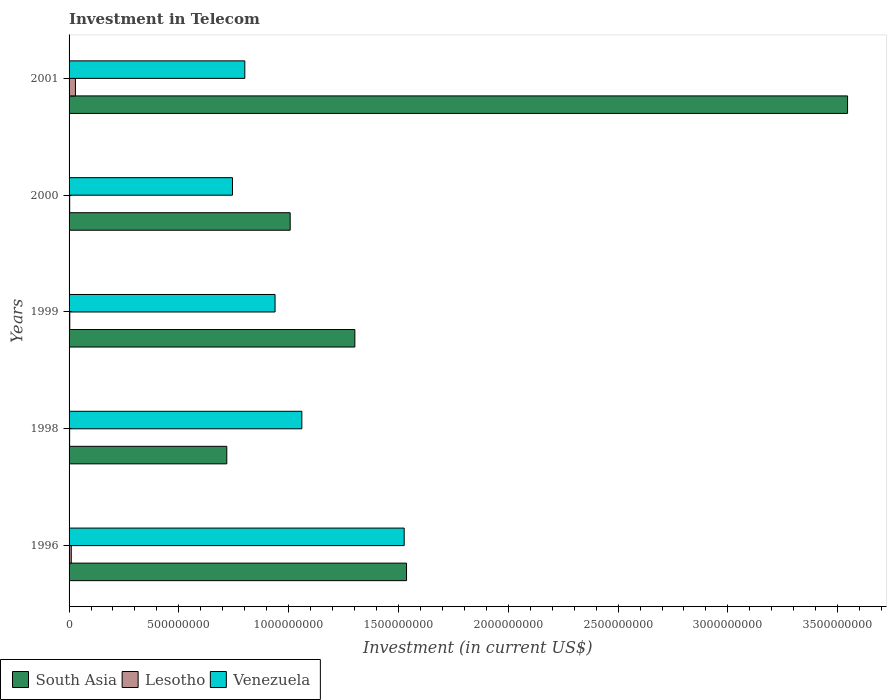How many groups of bars are there?
Provide a short and direct response. 5. Are the number of bars on each tick of the Y-axis equal?
Your answer should be very brief. Yes. How many bars are there on the 4th tick from the top?
Provide a short and direct response. 3. What is the label of the 4th group of bars from the top?
Provide a succinct answer. 1998. In how many cases, is the number of bars for a given year not equal to the number of legend labels?
Your answer should be very brief. 0. What is the amount invested in telecom in Lesotho in 1998?
Provide a succinct answer. 2.50e+06. Across all years, what is the maximum amount invested in telecom in South Asia?
Keep it short and to the point. 3.54e+09. Across all years, what is the minimum amount invested in telecom in Venezuela?
Your response must be concise. 7.44e+08. In which year was the amount invested in telecom in South Asia minimum?
Your answer should be very brief. 1998. What is the total amount invested in telecom in South Asia in the graph?
Your response must be concise. 8.11e+09. What is the difference between the amount invested in telecom in Venezuela in 1998 and that in 2000?
Offer a terse response. 3.16e+08. What is the difference between the amount invested in telecom in South Asia in 1996 and the amount invested in telecom in Venezuela in 1998?
Your answer should be compact. 4.77e+08. What is the average amount invested in telecom in Venezuela per year?
Ensure brevity in your answer.  1.01e+09. In the year 2001, what is the difference between the amount invested in telecom in Venezuela and amount invested in telecom in Lesotho?
Make the answer very short. 7.71e+08. What is the ratio of the amount invested in telecom in Lesotho in 1998 to that in 2000?
Your response must be concise. 0.89. Is the amount invested in telecom in Venezuela in 1996 less than that in 1999?
Your answer should be very brief. No. What is the difference between the highest and the second highest amount invested in telecom in South Asia?
Ensure brevity in your answer.  2.01e+09. What is the difference between the highest and the lowest amount invested in telecom in Lesotho?
Your answer should be very brief. 2.65e+07. In how many years, is the amount invested in telecom in Venezuela greater than the average amount invested in telecom in Venezuela taken over all years?
Offer a very short reply. 2. Is the sum of the amount invested in telecom in Venezuela in 1996 and 2001 greater than the maximum amount invested in telecom in South Asia across all years?
Offer a terse response. No. What does the 2nd bar from the top in 1999 represents?
Your answer should be compact. Lesotho. Is it the case that in every year, the sum of the amount invested in telecom in Lesotho and amount invested in telecom in Venezuela is greater than the amount invested in telecom in South Asia?
Give a very brief answer. No. How many bars are there?
Offer a very short reply. 15. Are all the bars in the graph horizontal?
Offer a terse response. Yes. What is the difference between two consecutive major ticks on the X-axis?
Keep it short and to the point. 5.00e+08. Does the graph contain any zero values?
Give a very brief answer. No. Does the graph contain grids?
Provide a short and direct response. No. How are the legend labels stacked?
Give a very brief answer. Horizontal. What is the title of the graph?
Your answer should be compact. Investment in Telecom. What is the label or title of the X-axis?
Your answer should be very brief. Investment (in current US$). What is the Investment (in current US$) in South Asia in 1996?
Ensure brevity in your answer.  1.54e+09. What is the Investment (in current US$) of Lesotho in 1996?
Provide a short and direct response. 1.00e+07. What is the Investment (in current US$) of Venezuela in 1996?
Your response must be concise. 1.53e+09. What is the Investment (in current US$) in South Asia in 1998?
Keep it short and to the point. 7.18e+08. What is the Investment (in current US$) in Lesotho in 1998?
Your answer should be compact. 2.50e+06. What is the Investment (in current US$) of Venezuela in 1998?
Your response must be concise. 1.06e+09. What is the Investment (in current US$) in South Asia in 1999?
Offer a terse response. 1.30e+09. What is the Investment (in current US$) in Lesotho in 1999?
Provide a succinct answer. 3.20e+06. What is the Investment (in current US$) in Venezuela in 1999?
Your answer should be compact. 9.38e+08. What is the Investment (in current US$) of South Asia in 2000?
Your answer should be compact. 1.01e+09. What is the Investment (in current US$) of Lesotho in 2000?
Make the answer very short. 2.80e+06. What is the Investment (in current US$) in Venezuela in 2000?
Offer a terse response. 7.44e+08. What is the Investment (in current US$) in South Asia in 2001?
Provide a short and direct response. 3.54e+09. What is the Investment (in current US$) of Lesotho in 2001?
Offer a terse response. 2.90e+07. What is the Investment (in current US$) in Venezuela in 2001?
Ensure brevity in your answer.  8.00e+08. Across all years, what is the maximum Investment (in current US$) of South Asia?
Provide a succinct answer. 3.54e+09. Across all years, what is the maximum Investment (in current US$) in Lesotho?
Your response must be concise. 2.90e+07. Across all years, what is the maximum Investment (in current US$) of Venezuela?
Keep it short and to the point. 1.53e+09. Across all years, what is the minimum Investment (in current US$) of South Asia?
Provide a succinct answer. 7.18e+08. Across all years, what is the minimum Investment (in current US$) in Lesotho?
Your answer should be compact. 2.50e+06. Across all years, what is the minimum Investment (in current US$) of Venezuela?
Provide a short and direct response. 7.44e+08. What is the total Investment (in current US$) in South Asia in the graph?
Make the answer very short. 8.11e+09. What is the total Investment (in current US$) in Lesotho in the graph?
Make the answer very short. 4.75e+07. What is the total Investment (in current US$) in Venezuela in the graph?
Provide a succinct answer. 5.07e+09. What is the difference between the Investment (in current US$) in South Asia in 1996 and that in 1998?
Your response must be concise. 8.18e+08. What is the difference between the Investment (in current US$) in Lesotho in 1996 and that in 1998?
Provide a succinct answer. 7.50e+06. What is the difference between the Investment (in current US$) in Venezuela in 1996 and that in 1998?
Provide a succinct answer. 4.66e+08. What is the difference between the Investment (in current US$) of South Asia in 1996 and that in 1999?
Offer a terse response. 2.35e+08. What is the difference between the Investment (in current US$) in Lesotho in 1996 and that in 1999?
Your answer should be very brief. 6.80e+06. What is the difference between the Investment (in current US$) of Venezuela in 1996 and that in 1999?
Your answer should be compact. 5.88e+08. What is the difference between the Investment (in current US$) in South Asia in 1996 and that in 2000?
Provide a succinct answer. 5.30e+08. What is the difference between the Investment (in current US$) in Lesotho in 1996 and that in 2000?
Ensure brevity in your answer.  7.20e+06. What is the difference between the Investment (in current US$) in Venezuela in 1996 and that in 2000?
Your answer should be compact. 7.82e+08. What is the difference between the Investment (in current US$) in South Asia in 1996 and that in 2001?
Provide a short and direct response. -2.01e+09. What is the difference between the Investment (in current US$) of Lesotho in 1996 and that in 2001?
Offer a terse response. -1.90e+07. What is the difference between the Investment (in current US$) of Venezuela in 1996 and that in 2001?
Your answer should be very brief. 7.26e+08. What is the difference between the Investment (in current US$) of South Asia in 1998 and that in 1999?
Ensure brevity in your answer.  -5.83e+08. What is the difference between the Investment (in current US$) of Lesotho in 1998 and that in 1999?
Offer a terse response. -7.00e+05. What is the difference between the Investment (in current US$) in Venezuela in 1998 and that in 1999?
Ensure brevity in your answer.  1.22e+08. What is the difference between the Investment (in current US$) of South Asia in 1998 and that in 2000?
Your answer should be compact. -2.89e+08. What is the difference between the Investment (in current US$) of Venezuela in 1998 and that in 2000?
Your answer should be compact. 3.16e+08. What is the difference between the Investment (in current US$) in South Asia in 1998 and that in 2001?
Your answer should be compact. -2.83e+09. What is the difference between the Investment (in current US$) in Lesotho in 1998 and that in 2001?
Provide a short and direct response. -2.65e+07. What is the difference between the Investment (in current US$) in Venezuela in 1998 and that in 2001?
Your response must be concise. 2.60e+08. What is the difference between the Investment (in current US$) in South Asia in 1999 and that in 2000?
Give a very brief answer. 2.94e+08. What is the difference between the Investment (in current US$) in Venezuela in 1999 and that in 2000?
Give a very brief answer. 1.94e+08. What is the difference between the Investment (in current US$) in South Asia in 1999 and that in 2001?
Offer a terse response. -2.24e+09. What is the difference between the Investment (in current US$) of Lesotho in 1999 and that in 2001?
Provide a succinct answer. -2.58e+07. What is the difference between the Investment (in current US$) in Venezuela in 1999 and that in 2001?
Your answer should be very brief. 1.38e+08. What is the difference between the Investment (in current US$) in South Asia in 2000 and that in 2001?
Ensure brevity in your answer.  -2.54e+09. What is the difference between the Investment (in current US$) in Lesotho in 2000 and that in 2001?
Give a very brief answer. -2.62e+07. What is the difference between the Investment (in current US$) of Venezuela in 2000 and that in 2001?
Keep it short and to the point. -5.62e+07. What is the difference between the Investment (in current US$) in South Asia in 1996 and the Investment (in current US$) in Lesotho in 1998?
Your answer should be compact. 1.53e+09. What is the difference between the Investment (in current US$) of South Asia in 1996 and the Investment (in current US$) of Venezuela in 1998?
Provide a short and direct response. 4.77e+08. What is the difference between the Investment (in current US$) in Lesotho in 1996 and the Investment (in current US$) in Venezuela in 1998?
Your answer should be compact. -1.05e+09. What is the difference between the Investment (in current US$) of South Asia in 1996 and the Investment (in current US$) of Lesotho in 1999?
Ensure brevity in your answer.  1.53e+09. What is the difference between the Investment (in current US$) of South Asia in 1996 and the Investment (in current US$) of Venezuela in 1999?
Keep it short and to the point. 5.99e+08. What is the difference between the Investment (in current US$) of Lesotho in 1996 and the Investment (in current US$) of Venezuela in 1999?
Ensure brevity in your answer.  -9.28e+08. What is the difference between the Investment (in current US$) in South Asia in 1996 and the Investment (in current US$) in Lesotho in 2000?
Offer a very short reply. 1.53e+09. What is the difference between the Investment (in current US$) in South Asia in 1996 and the Investment (in current US$) in Venezuela in 2000?
Offer a terse response. 7.93e+08. What is the difference between the Investment (in current US$) of Lesotho in 1996 and the Investment (in current US$) of Venezuela in 2000?
Keep it short and to the point. -7.34e+08. What is the difference between the Investment (in current US$) in South Asia in 1996 and the Investment (in current US$) in Lesotho in 2001?
Give a very brief answer. 1.51e+09. What is the difference between the Investment (in current US$) in South Asia in 1996 and the Investment (in current US$) in Venezuela in 2001?
Your answer should be very brief. 7.36e+08. What is the difference between the Investment (in current US$) in Lesotho in 1996 and the Investment (in current US$) in Venezuela in 2001?
Offer a very short reply. -7.90e+08. What is the difference between the Investment (in current US$) of South Asia in 1998 and the Investment (in current US$) of Lesotho in 1999?
Give a very brief answer. 7.15e+08. What is the difference between the Investment (in current US$) in South Asia in 1998 and the Investment (in current US$) in Venezuela in 1999?
Keep it short and to the point. -2.20e+08. What is the difference between the Investment (in current US$) of Lesotho in 1998 and the Investment (in current US$) of Venezuela in 1999?
Provide a short and direct response. -9.36e+08. What is the difference between the Investment (in current US$) of South Asia in 1998 and the Investment (in current US$) of Lesotho in 2000?
Give a very brief answer. 7.15e+08. What is the difference between the Investment (in current US$) in South Asia in 1998 and the Investment (in current US$) in Venezuela in 2000?
Offer a terse response. -2.59e+07. What is the difference between the Investment (in current US$) in Lesotho in 1998 and the Investment (in current US$) in Venezuela in 2000?
Your answer should be very brief. -7.42e+08. What is the difference between the Investment (in current US$) of South Asia in 1998 and the Investment (in current US$) of Lesotho in 2001?
Keep it short and to the point. 6.89e+08. What is the difference between the Investment (in current US$) of South Asia in 1998 and the Investment (in current US$) of Venezuela in 2001?
Your answer should be very brief. -8.21e+07. What is the difference between the Investment (in current US$) of Lesotho in 1998 and the Investment (in current US$) of Venezuela in 2001?
Give a very brief answer. -7.98e+08. What is the difference between the Investment (in current US$) of South Asia in 1999 and the Investment (in current US$) of Lesotho in 2000?
Offer a terse response. 1.30e+09. What is the difference between the Investment (in current US$) of South Asia in 1999 and the Investment (in current US$) of Venezuela in 2000?
Offer a terse response. 5.57e+08. What is the difference between the Investment (in current US$) of Lesotho in 1999 and the Investment (in current US$) of Venezuela in 2000?
Offer a very short reply. -7.41e+08. What is the difference between the Investment (in current US$) of South Asia in 1999 and the Investment (in current US$) of Lesotho in 2001?
Ensure brevity in your answer.  1.27e+09. What is the difference between the Investment (in current US$) in South Asia in 1999 and the Investment (in current US$) in Venezuela in 2001?
Offer a terse response. 5.01e+08. What is the difference between the Investment (in current US$) of Lesotho in 1999 and the Investment (in current US$) of Venezuela in 2001?
Provide a short and direct response. -7.97e+08. What is the difference between the Investment (in current US$) of South Asia in 2000 and the Investment (in current US$) of Lesotho in 2001?
Your answer should be very brief. 9.78e+08. What is the difference between the Investment (in current US$) in South Asia in 2000 and the Investment (in current US$) in Venezuela in 2001?
Offer a terse response. 2.07e+08. What is the difference between the Investment (in current US$) in Lesotho in 2000 and the Investment (in current US$) in Venezuela in 2001?
Provide a short and direct response. -7.98e+08. What is the average Investment (in current US$) of South Asia per year?
Your answer should be very brief. 1.62e+09. What is the average Investment (in current US$) in Lesotho per year?
Offer a very short reply. 9.50e+06. What is the average Investment (in current US$) in Venezuela per year?
Ensure brevity in your answer.  1.01e+09. In the year 1996, what is the difference between the Investment (in current US$) of South Asia and Investment (in current US$) of Lesotho?
Your response must be concise. 1.53e+09. In the year 1996, what is the difference between the Investment (in current US$) of South Asia and Investment (in current US$) of Venezuela?
Your answer should be compact. 1.07e+07. In the year 1996, what is the difference between the Investment (in current US$) of Lesotho and Investment (in current US$) of Venezuela?
Ensure brevity in your answer.  -1.52e+09. In the year 1998, what is the difference between the Investment (in current US$) of South Asia and Investment (in current US$) of Lesotho?
Ensure brevity in your answer.  7.16e+08. In the year 1998, what is the difference between the Investment (in current US$) of South Asia and Investment (in current US$) of Venezuela?
Provide a succinct answer. -3.42e+08. In the year 1998, what is the difference between the Investment (in current US$) in Lesotho and Investment (in current US$) in Venezuela?
Make the answer very short. -1.06e+09. In the year 1999, what is the difference between the Investment (in current US$) of South Asia and Investment (in current US$) of Lesotho?
Make the answer very short. 1.30e+09. In the year 1999, what is the difference between the Investment (in current US$) in South Asia and Investment (in current US$) in Venezuela?
Offer a very short reply. 3.63e+08. In the year 1999, what is the difference between the Investment (in current US$) of Lesotho and Investment (in current US$) of Venezuela?
Provide a short and direct response. -9.35e+08. In the year 2000, what is the difference between the Investment (in current US$) in South Asia and Investment (in current US$) in Lesotho?
Provide a succinct answer. 1.00e+09. In the year 2000, what is the difference between the Investment (in current US$) of South Asia and Investment (in current US$) of Venezuela?
Your answer should be very brief. 2.63e+08. In the year 2000, what is the difference between the Investment (in current US$) in Lesotho and Investment (in current US$) in Venezuela?
Your answer should be compact. -7.41e+08. In the year 2001, what is the difference between the Investment (in current US$) of South Asia and Investment (in current US$) of Lesotho?
Offer a terse response. 3.52e+09. In the year 2001, what is the difference between the Investment (in current US$) in South Asia and Investment (in current US$) in Venezuela?
Offer a very short reply. 2.74e+09. In the year 2001, what is the difference between the Investment (in current US$) in Lesotho and Investment (in current US$) in Venezuela?
Keep it short and to the point. -7.71e+08. What is the ratio of the Investment (in current US$) in South Asia in 1996 to that in 1998?
Provide a short and direct response. 2.14. What is the ratio of the Investment (in current US$) in Lesotho in 1996 to that in 1998?
Your answer should be very brief. 4. What is the ratio of the Investment (in current US$) in Venezuela in 1996 to that in 1998?
Provide a short and direct response. 1.44. What is the ratio of the Investment (in current US$) in South Asia in 1996 to that in 1999?
Provide a short and direct response. 1.18. What is the ratio of the Investment (in current US$) in Lesotho in 1996 to that in 1999?
Your answer should be very brief. 3.12. What is the ratio of the Investment (in current US$) of Venezuela in 1996 to that in 1999?
Your response must be concise. 1.63. What is the ratio of the Investment (in current US$) in South Asia in 1996 to that in 2000?
Keep it short and to the point. 1.53. What is the ratio of the Investment (in current US$) of Lesotho in 1996 to that in 2000?
Provide a succinct answer. 3.57. What is the ratio of the Investment (in current US$) of Venezuela in 1996 to that in 2000?
Offer a terse response. 2.05. What is the ratio of the Investment (in current US$) in South Asia in 1996 to that in 2001?
Keep it short and to the point. 0.43. What is the ratio of the Investment (in current US$) in Lesotho in 1996 to that in 2001?
Give a very brief answer. 0.34. What is the ratio of the Investment (in current US$) of Venezuela in 1996 to that in 2001?
Provide a short and direct response. 1.91. What is the ratio of the Investment (in current US$) in South Asia in 1998 to that in 1999?
Keep it short and to the point. 0.55. What is the ratio of the Investment (in current US$) in Lesotho in 1998 to that in 1999?
Offer a very short reply. 0.78. What is the ratio of the Investment (in current US$) in Venezuela in 1998 to that in 1999?
Keep it short and to the point. 1.13. What is the ratio of the Investment (in current US$) in South Asia in 1998 to that in 2000?
Give a very brief answer. 0.71. What is the ratio of the Investment (in current US$) in Lesotho in 1998 to that in 2000?
Keep it short and to the point. 0.89. What is the ratio of the Investment (in current US$) of Venezuela in 1998 to that in 2000?
Your answer should be very brief. 1.42. What is the ratio of the Investment (in current US$) in South Asia in 1998 to that in 2001?
Offer a terse response. 0.2. What is the ratio of the Investment (in current US$) in Lesotho in 1998 to that in 2001?
Provide a short and direct response. 0.09. What is the ratio of the Investment (in current US$) in Venezuela in 1998 to that in 2001?
Your response must be concise. 1.32. What is the ratio of the Investment (in current US$) in South Asia in 1999 to that in 2000?
Ensure brevity in your answer.  1.29. What is the ratio of the Investment (in current US$) in Lesotho in 1999 to that in 2000?
Make the answer very short. 1.14. What is the ratio of the Investment (in current US$) in Venezuela in 1999 to that in 2000?
Provide a short and direct response. 1.26. What is the ratio of the Investment (in current US$) in South Asia in 1999 to that in 2001?
Ensure brevity in your answer.  0.37. What is the ratio of the Investment (in current US$) of Lesotho in 1999 to that in 2001?
Ensure brevity in your answer.  0.11. What is the ratio of the Investment (in current US$) in Venezuela in 1999 to that in 2001?
Keep it short and to the point. 1.17. What is the ratio of the Investment (in current US$) in South Asia in 2000 to that in 2001?
Offer a very short reply. 0.28. What is the ratio of the Investment (in current US$) of Lesotho in 2000 to that in 2001?
Keep it short and to the point. 0.1. What is the ratio of the Investment (in current US$) in Venezuela in 2000 to that in 2001?
Give a very brief answer. 0.93. What is the difference between the highest and the second highest Investment (in current US$) in South Asia?
Give a very brief answer. 2.01e+09. What is the difference between the highest and the second highest Investment (in current US$) of Lesotho?
Your response must be concise. 1.90e+07. What is the difference between the highest and the second highest Investment (in current US$) in Venezuela?
Offer a very short reply. 4.66e+08. What is the difference between the highest and the lowest Investment (in current US$) in South Asia?
Keep it short and to the point. 2.83e+09. What is the difference between the highest and the lowest Investment (in current US$) of Lesotho?
Give a very brief answer. 2.65e+07. What is the difference between the highest and the lowest Investment (in current US$) in Venezuela?
Give a very brief answer. 7.82e+08. 